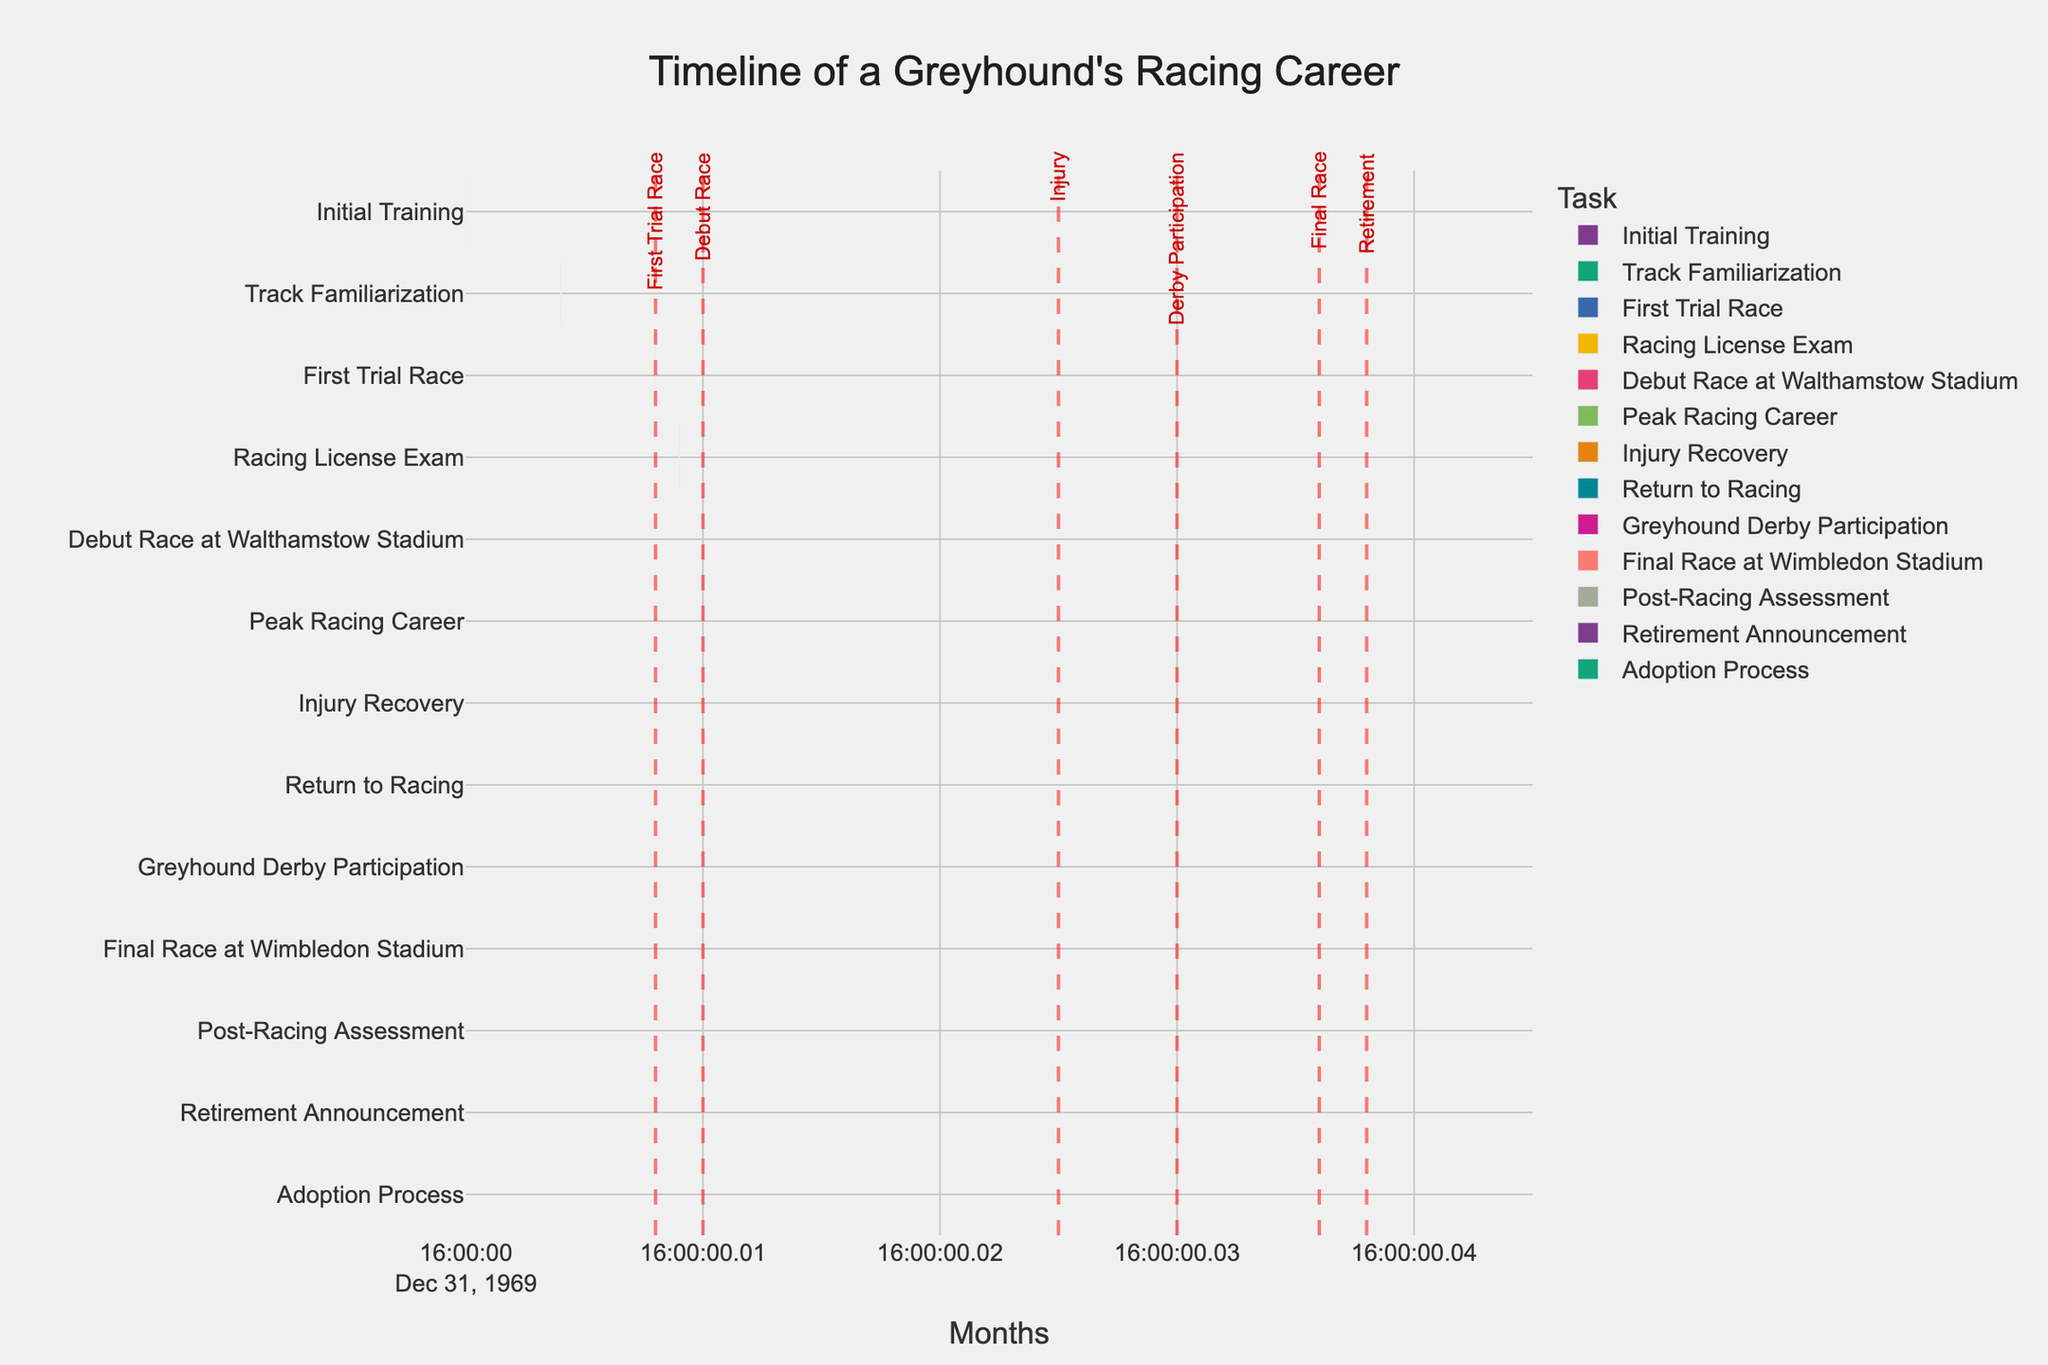When does the greyhound's Initial Training begin? The Initial Training task is shown on the Gantt chart starting at month 0.
Answer: Month 0 What is the duration of the Peak Racing Career? The Peak Racing Career task spans from month 11 to month 36. The duration can be calculated by subtracting the start month from the end month: 36 - 11 = 25 months.
Answer: 25 months How long does the Injury Recovery period last? Injury Recovery spans from month 25 to month 28. The duration is 28 - 25 = 3 months.
Answer: 3 months Which event occurs first, the Greyhound Derby Participation or the Final Race at Wimbledon Stadium? Greyhound Derby Participation occurs at month 30, while the Final Race at Wimbledon Stadium occurs at month 36. The Greyhound Derby Participation takes place earlier.
Answer: Greyhound Derby Participation Compare the start times of Track Familiarization and Post-Racing Assessment. Which one starts first? Track Familiarization starts at month 4 and Post-Racing Assessment starts at month 37. Track Familiarization starts earlier than Post-Racing Assessment.
Answer: Track Familiarization How long after the Debut Race at Walthamstow Stadium does the greyhound participate in the Greyhound Derby? The Debut Race at Walthamstow Stadium is in month 10, and Greyhound Derby Participation is in month 30. The difference is 30 - 10 = 20 months.
Answer: 20 months What major event happens around month 25? Around month 25, the greyhound faces an injury, as indicated by the Injury Recovery period starting at month 25.
Answer: Injury How many months does it take from the Retirement Announcement to the end of the Adoption Process? The Retirement Announcement is in month 38, and the Adoption Process ends in month 42. The duration from Retirement Announcement to the end of the Adoption Process is 42 - 38 = 4 months.
Answer: 4 months During which months are the Initial Training and Track Familiarization tasks overlapping? Initial Training is from month 0 to month 6 and Track Familiarization is from month 4 to month 8. The overlapping period is from month 4 to month 6.
Answer: Months 4-6 